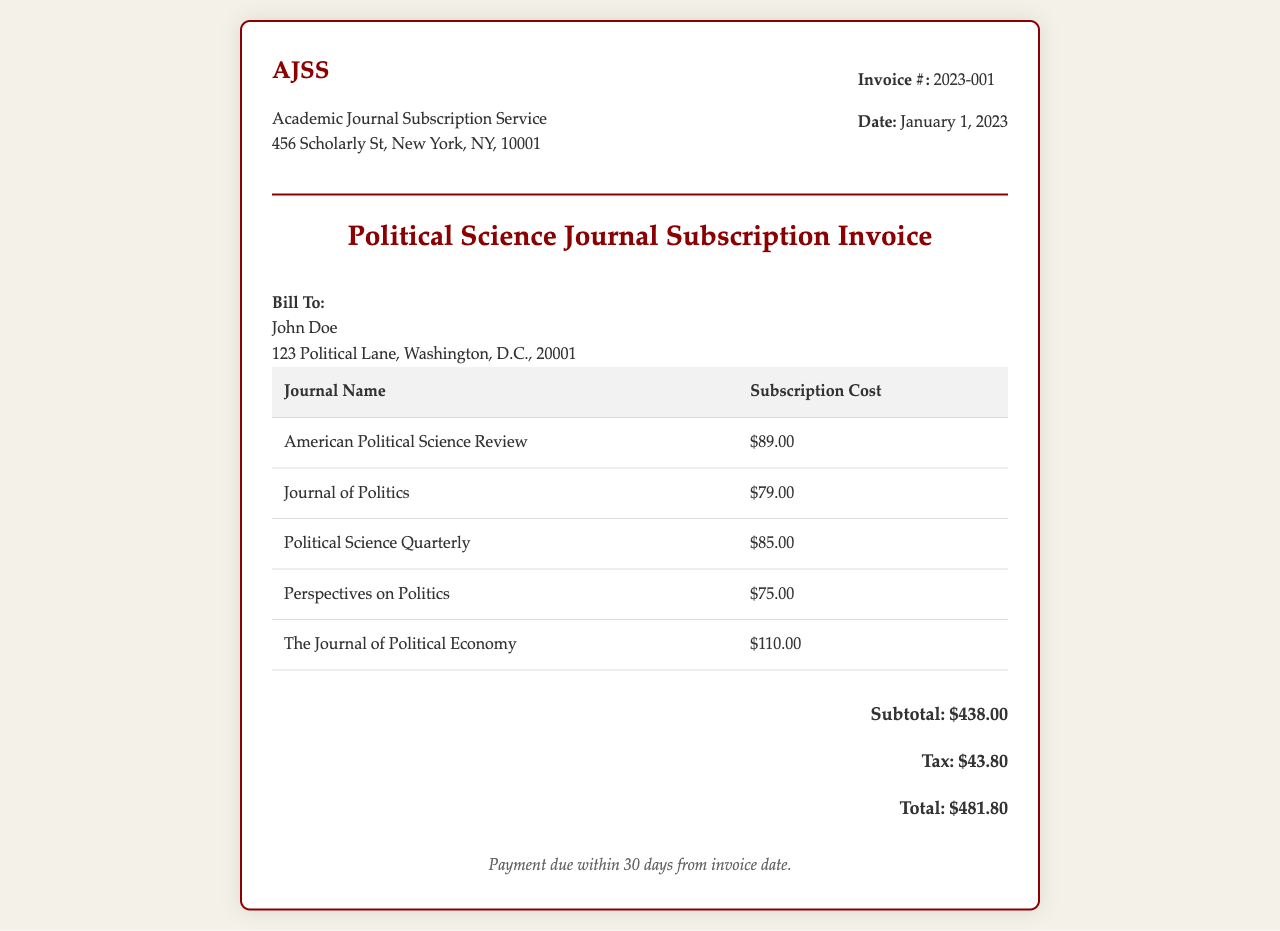what is the invoice number? The invoice number is listed near the top of the document, indicating its unique identifier, which is 2023-001.
Answer: 2023-001 what is the total amount due? The total amount due is calculated after adding the subtotal and tax, which is $481.80.
Answer: $481.80 who is the invoice addressed to? The invoice includes a billing section that specifies the recipient's name, which is John Doe.
Answer: John Doe how much is the subscription cost for the Journal of Politics? The subscription cost for the Journal of Politics is stated in the table of journal costs as $79.00.
Answer: $79.00 what is the subtotal for the subscriptions? The subtotal is provided at the bottom of the document, summing all the individual journal costs to arrive at $438.00.
Answer: $438.00 what is the cost of the most expensive journal? The most expensive journal listed is The Journal of Political Economy, which costs $110.00.
Answer: $110.00 what percentage of tax is applied to the subtotal? The tax amount is calculated based on the subtotal, which is $43.80, indicating a 10% tax rate.
Answer: 10% when is the payment due? The due date is mentioned clearly in the terms section, indicating that payment is due within 30 days from the invoice date.
Answer: 30 days 